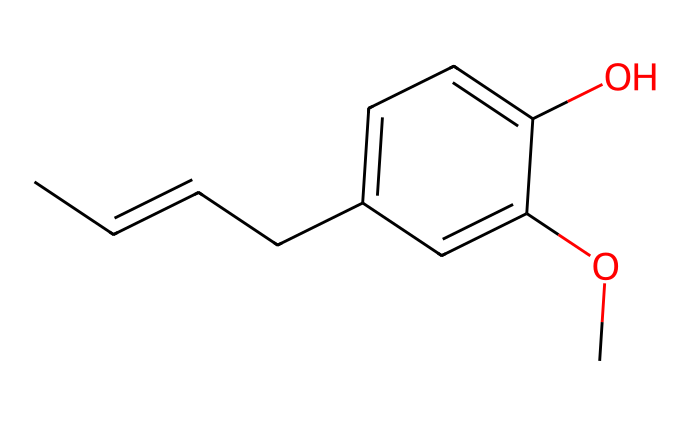How many carbon atoms are in eugenol? By analyzing the SMILES representation, we can count the number of carbon atoms (C). Each 'C' in the representation corresponds to one carbon atom, and we can also deduce from the molecular structure confirmed by the given SMILES that there are 10 carbon atoms.
Answer: 10 What functional groups are present in eugenol? By identifying the groups in the SMILES, we see the presence of an –OH (hydroxyl) group and an –O–CH3 (methoxy) group attached to the benzene ring. These functional groups contribute to the characteristics of eugenol.
Answer: hydroxyl and methoxy Is eugenol a polar or nonpolar compound? Considering the presence of the hydroxyl functional group (–OH) and the methoxy group (–O–CH3) in eugenol, which introduce some polarity, the molecule leans toward being polar overall due to these functional groups outweighing the nonpolar hydrocarbon part.
Answer: polar What is the primary aromatic component of eugenol? Analyzing the structure from the SMILES, the benzene ring is clearly visible, which is a characteristic feature of aromatic compounds. Thus, the primary aromatic component is the benzene ring.
Answer: benzene ring How many double bonds are present in eugenol? The SMILES structure shows not only the aromatic ring but also a double bond between carbons in the aliphatic chain at the beginning (CC=CC). By counting these, we identify there are two double bonds in total within the entire molecule: one in the chain and one in the benzene.
Answer: 2 What type of isomerism could eugenol potentially exhibit? The structure depicted in the SMILES contains both a double bond and a benzene ring. The presence of both unsaturation (double bond) and substituents indicates that eugenol could exhibit geometric (cis/trans) isomerism due to the restricted rotation around the double bond.
Answer: geometric isomerism 